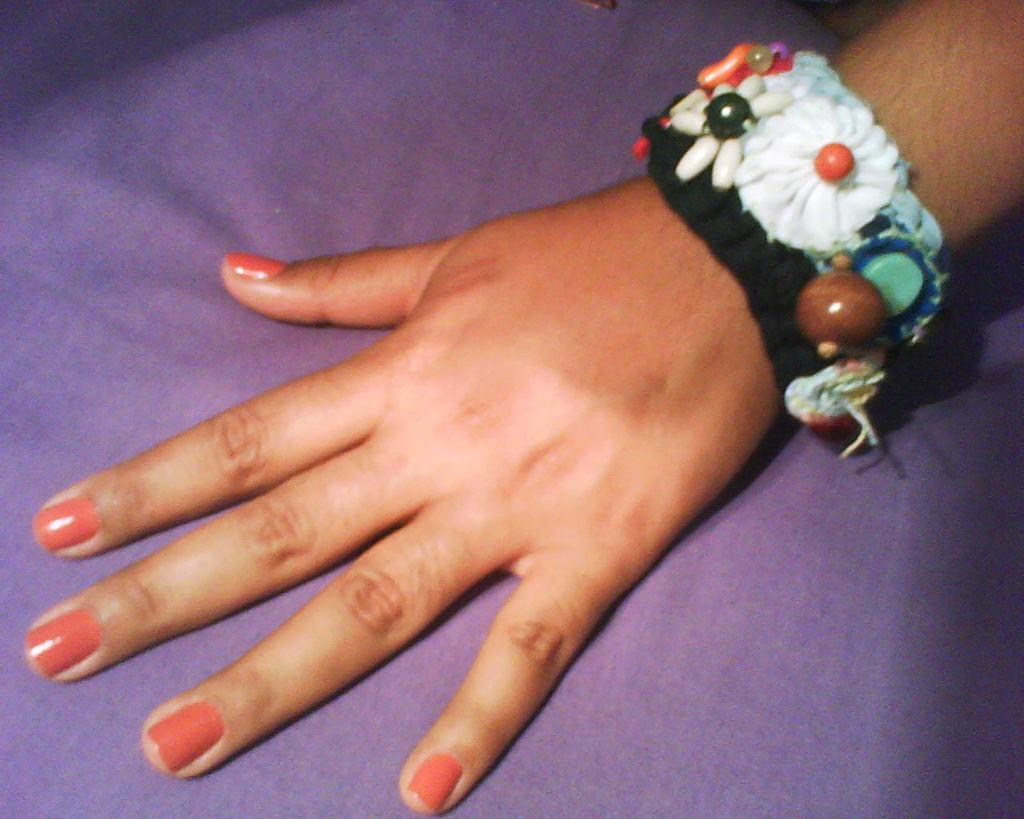What part of the human body is visible in the image? There is a human hand in the image. What is on the hand in the image? There is a band on the hand. What color is the band on the hand? The band is purple in color. What type of flag is being waved by the nose in the image? There is no flag or nose present in the image; it only features a human hand with a purple band on it. 